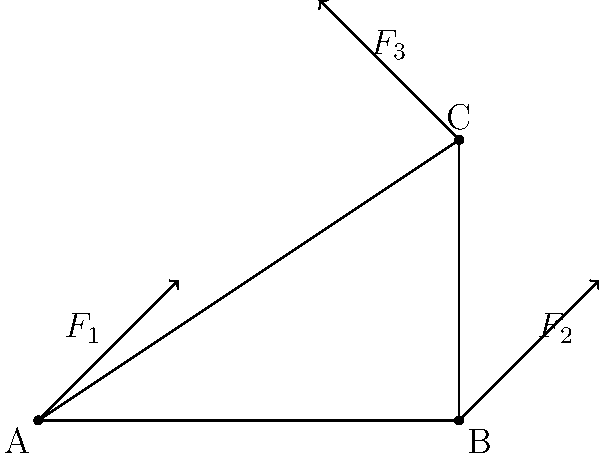In a game physics engine, a triangular object ABC is subjected to three forces $F_1$, $F_2$, and $F_3$ as shown in the diagram. If the object is in equilibrium, which of the following statements must be true?

1. $F_1 + F_2 + F_3 = 0$
2. The lines of action of all three forces must intersect at a single point
3. The sum of the moments about any point must be zero
4. All of the above To solve this problem, let's consider the conditions for equilibrium in a 2D system:

1. Force equilibrium: The vector sum of all forces must be zero.
   $$\sum F = 0$$

2. Moment equilibrium: The sum of moments about any point must be zero.
   $$\sum M = 0$$

Now, let's analyze each statement:

1. $F_1 + F_2 + F_3 = 0$
   This is correct. For the object to be in equilibrium, the vector sum of all forces must be zero.

2. The lines of action of all three forces must intersect at a single point
   This is not necessarily true. While this condition (known as the "triangle of forces") can occur in some equilibrium situations, it's not a requirement for equilibrium.

3. The sum of the moments about any point must be zero
   This is correct. For rotational equilibrium, the sum of moments about any point must be zero.

4. All of the above
   This is incorrect because statement 2 is not always true.

In a game physics engine, both force and moment equilibrium are crucial for realistic object behavior. The engine would use these principles to calculate the object's position and orientation in each frame.
Answer: 1 and 3 